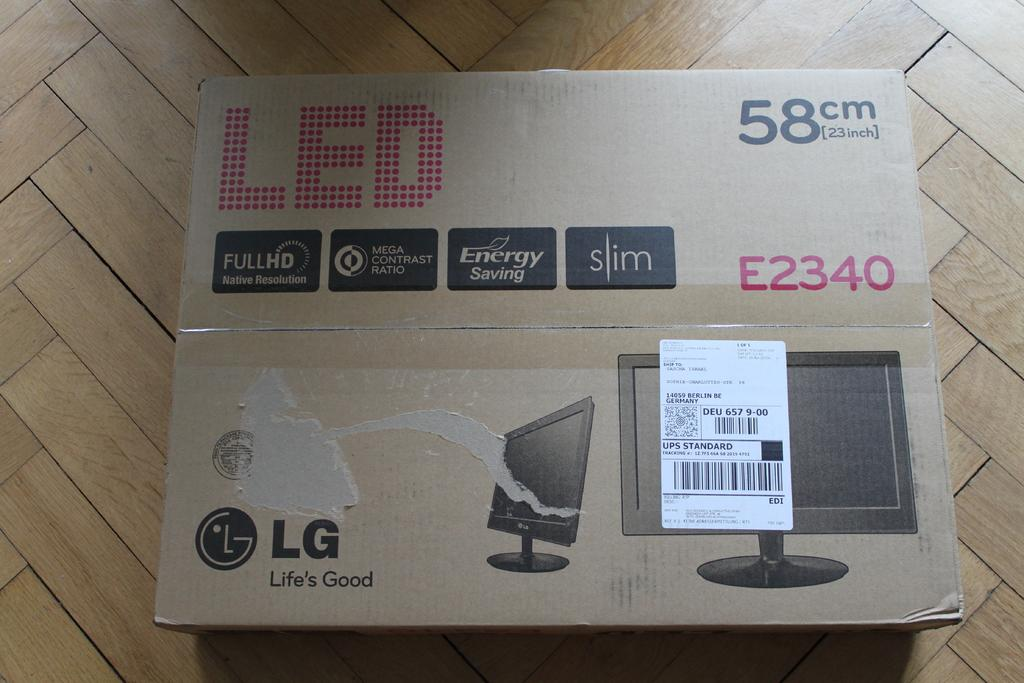<image>
Write a terse but informative summary of the picture. A box for an LED monitor by LG holds a 23 inch product. 